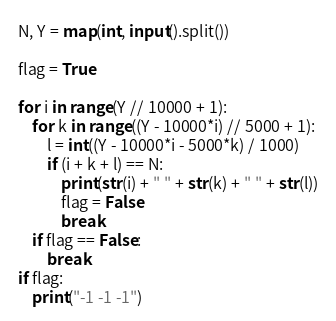<code> <loc_0><loc_0><loc_500><loc_500><_Python_>N, Y = map(int, input().split())

flag = True

for i in range(Y // 10000 + 1):
    for k in range((Y - 10000*i) // 5000 + 1):
        l = int((Y - 10000*i - 5000*k) / 1000)
        if (i + k + l) == N:
            print(str(i) + " " + str(k) + " " + str(l))
            flag = False
            break
    if flag == False:
        break
if flag:
    print("-1 -1 -1")</code> 